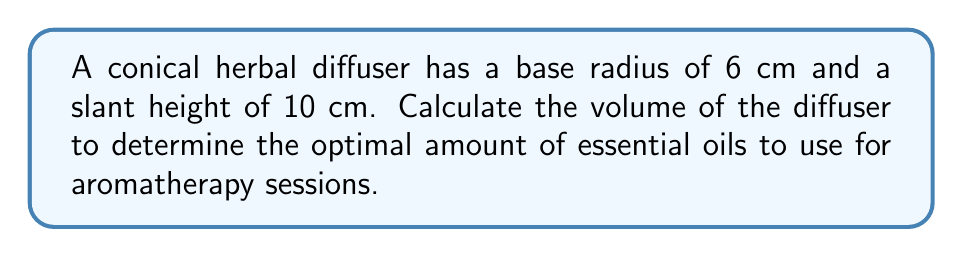Teach me how to tackle this problem. To find the volume of a cone, we need to use the formula:

$$V = \frac{1}{3}\pi r^2 h$$

Where $r$ is the radius of the base and $h$ is the height of the cone.

We are given the base radius $r = 6$ cm and the slant height $s = 10$ cm. We need to find the height $h$ using trigonometry.

1) First, let's visualize the cone:

[asy]
import geometry;

size(100);
pair A = (0,0), B = (6,0), C = (0,8);
draw(A--B--C--A);
draw(B--(6,8),dashed);
label("r = 6", (3,-0.5), S);
label("s = 10", (7,4), E);
label("h", (-0.5,4), W);
[/asy]

2) We can see that the height $h$ and radius $r$ form a right triangle with the slant height $s$. We can use the Pythagorean theorem:

   $$s^2 = r^2 + h^2$$

3) Substituting the known values:

   $$10^2 = 6^2 + h^2$$

4) Simplify:

   $$100 = 36 + h^2$$

5) Solve for $h$:

   $$h^2 = 100 - 36 = 64$$
   $$h = \sqrt{64} = 8$$

6) Now that we have $h$, we can calculate the volume:

   $$V = \frac{1}{3}\pi r^2 h$$
   $$V = \frac{1}{3}\pi (6\text{ cm})^2 (8\text{ cm})$$
   $$V = \frac{1}{3}\pi (36\text{ cm}^2) (8\text{ cm})$$
   $$V = 96\pi\text{ cm}^3$$

7) Simplifying:

   $$V \approx 301.59\text{ cm}^3$$
Answer: $301.59\text{ cm}^3$ 